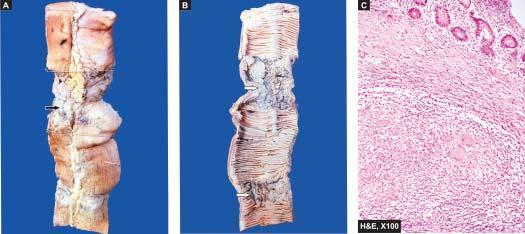what does the external surface of small intestine show?
Answer the question using a single word or phrase. Stricture and a lymph node in section having caseation necrosiss 